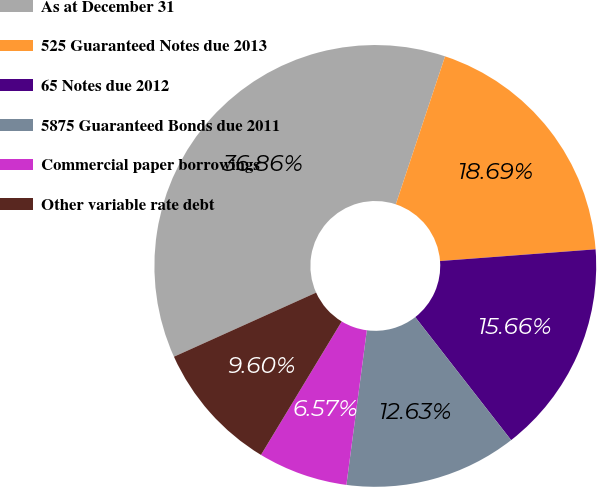<chart> <loc_0><loc_0><loc_500><loc_500><pie_chart><fcel>As at December 31<fcel>525 Guaranteed Notes due 2013<fcel>65 Notes due 2012<fcel>5875 Guaranteed Bonds due 2011<fcel>Commercial paper borrowings<fcel>Other variable rate debt<nl><fcel>36.86%<fcel>18.69%<fcel>15.66%<fcel>12.63%<fcel>6.57%<fcel>9.6%<nl></chart> 